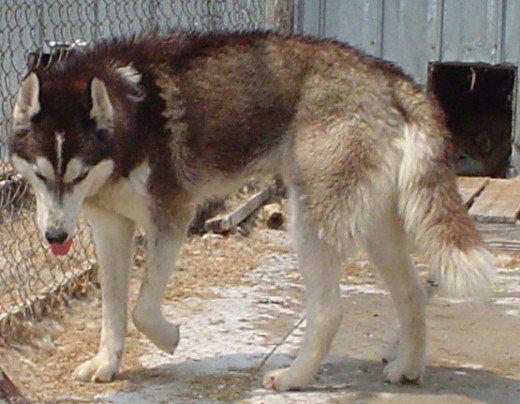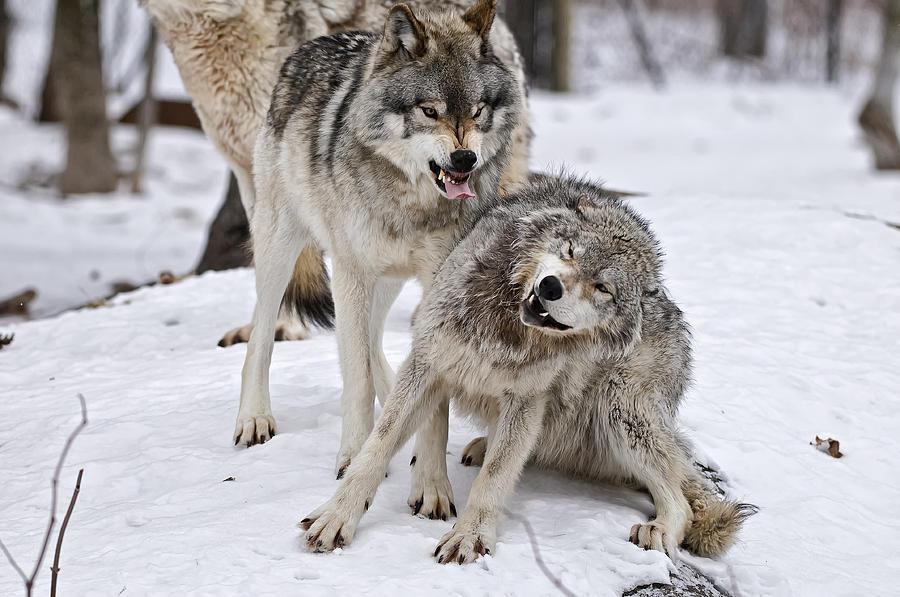The first image is the image on the left, the second image is the image on the right. Analyze the images presented: Is the assertion "Two animals have their tongues out." valid? Answer yes or no. Yes. The first image is the image on the left, the second image is the image on the right. Considering the images on both sides, is "The left image shows a single adult, wolf with one front paw off the ground and its head somewhat lowered and facing forward." valid? Answer yes or no. Yes. 